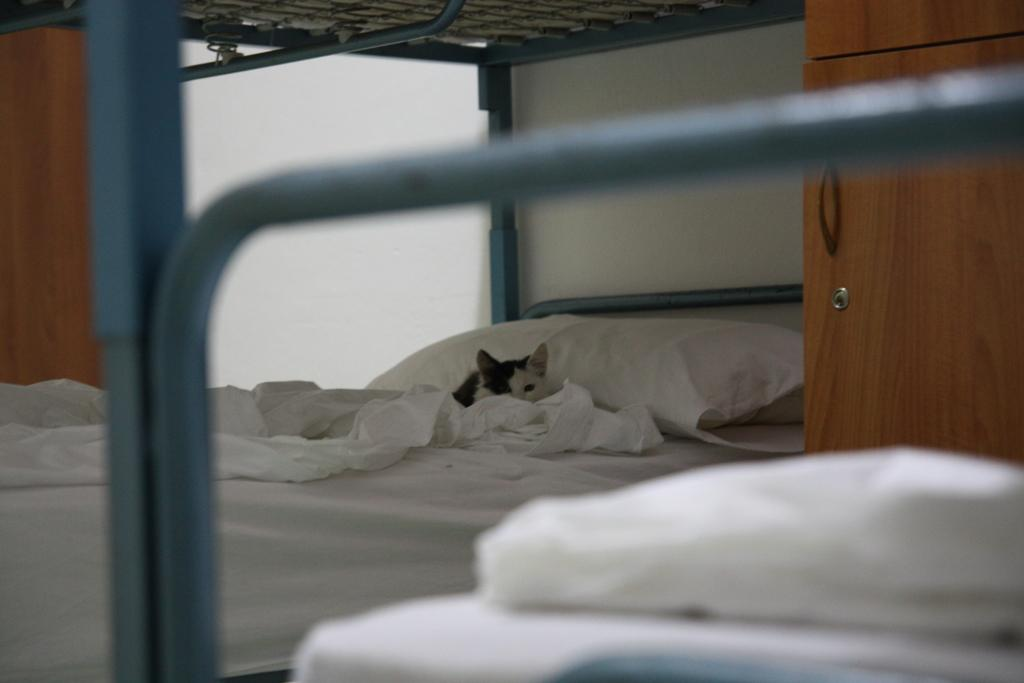What piece of furniture is present in the image? There is a bed in the image. What is covering the bed? The bed has a blanket. What is used for head support on the bed? The bed has a pillow. What type of animal can be seen on the bed? There is a small kitten laying on the bed. What type of pollution can be seen in the image? There is no pollution present in the image; it features a bed with a blanket, pillow, and a small kitten. What type of produce is visible on the bed? There is no produce present in the image; it features a bed with a blanket, pillow, and a small kitten. 